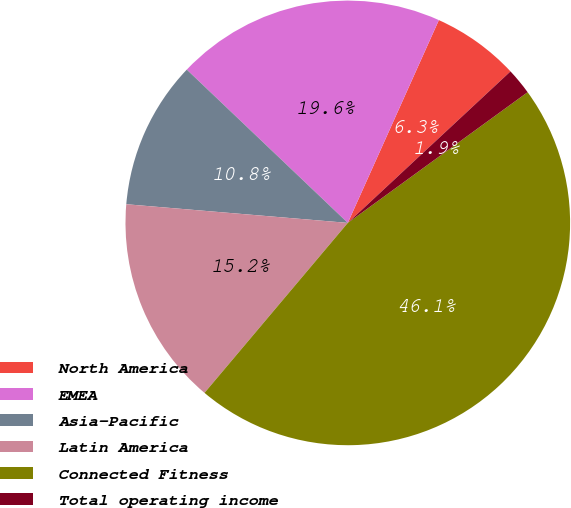<chart> <loc_0><loc_0><loc_500><loc_500><pie_chart><fcel>North America<fcel>EMEA<fcel>Asia-Pacific<fcel>Latin America<fcel>Connected Fitness<fcel>Total operating income<nl><fcel>6.35%<fcel>19.61%<fcel>10.77%<fcel>15.19%<fcel>46.15%<fcel>1.93%<nl></chart> 